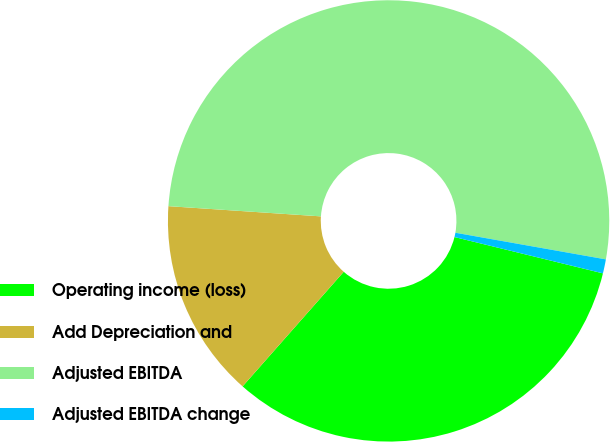Convert chart. <chart><loc_0><loc_0><loc_500><loc_500><pie_chart><fcel>Operating income (loss)<fcel>Add Depreciation and<fcel>Adjusted EBITDA<fcel>Adjusted EBITDA change<nl><fcel>32.69%<fcel>14.56%<fcel>51.73%<fcel>1.03%<nl></chart> 